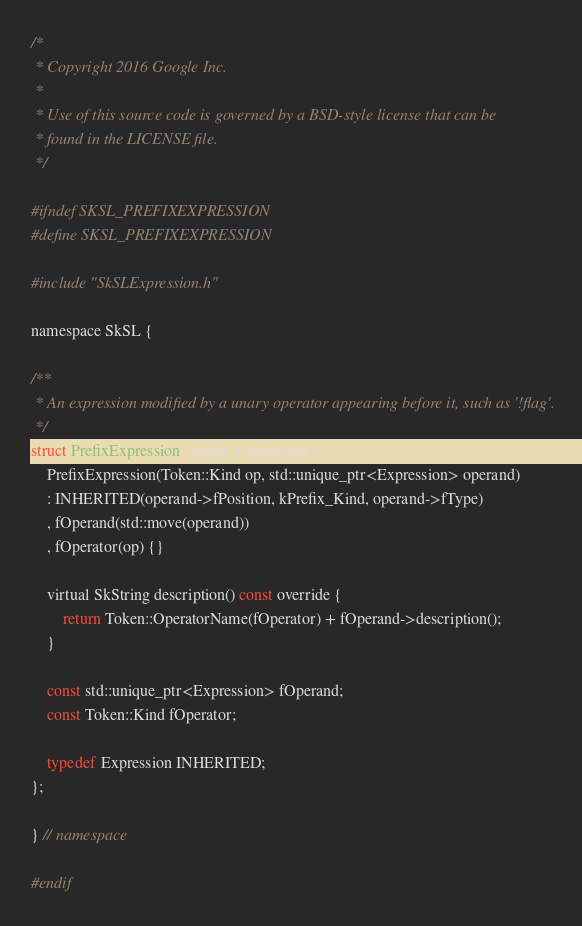Convert code to text. <code><loc_0><loc_0><loc_500><loc_500><_C_>/*
 * Copyright 2016 Google Inc.
 *
 * Use of this source code is governed by a BSD-style license that can be
 * found in the LICENSE file.
 */
 
#ifndef SKSL_PREFIXEXPRESSION
#define SKSL_PREFIXEXPRESSION

#include "SkSLExpression.h"

namespace SkSL {

/**
 * An expression modified by a unary operator appearing before it, such as '!flag'.
 */
struct PrefixExpression : public Expression {
    PrefixExpression(Token::Kind op, std::unique_ptr<Expression> operand)
    : INHERITED(operand->fPosition, kPrefix_Kind, operand->fType)
    , fOperand(std::move(operand))
    , fOperator(op) {}

    virtual SkString description() const override {
        return Token::OperatorName(fOperator) + fOperand->description();
    }

    const std::unique_ptr<Expression> fOperand;
    const Token::Kind fOperator;

    typedef Expression INHERITED;
};

} // namespace

#endif
</code> 